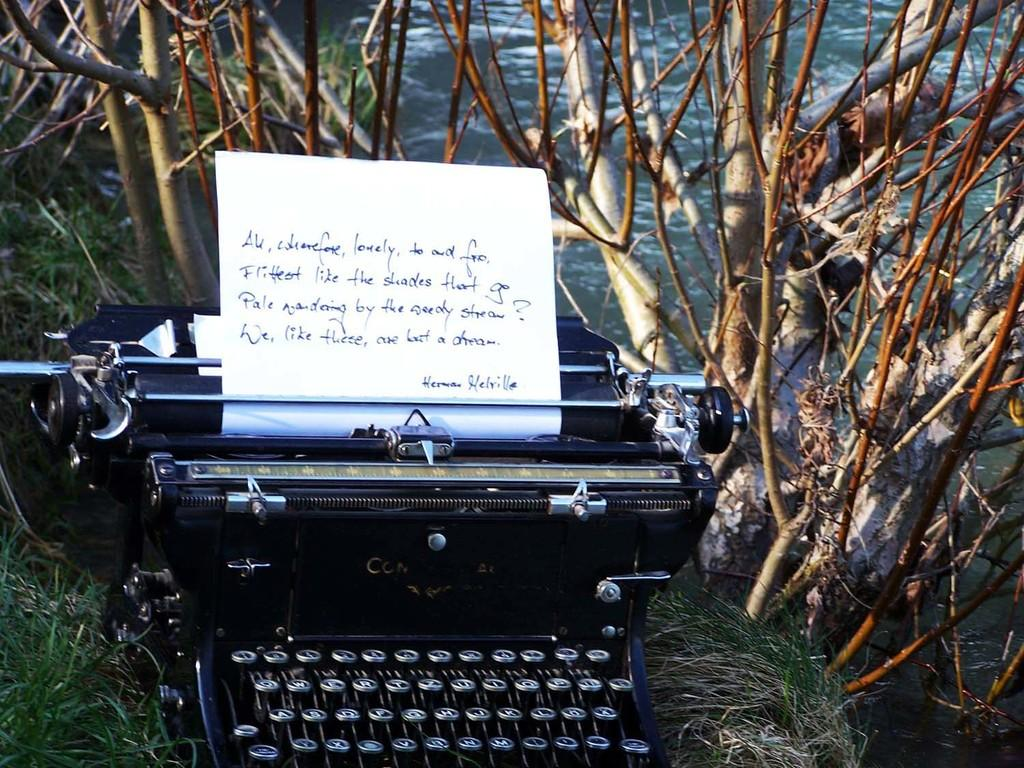<image>
Render a clear and concise summary of the photo. A typewriter is in the weeds, on the paper is a quote from Herman Melville. 